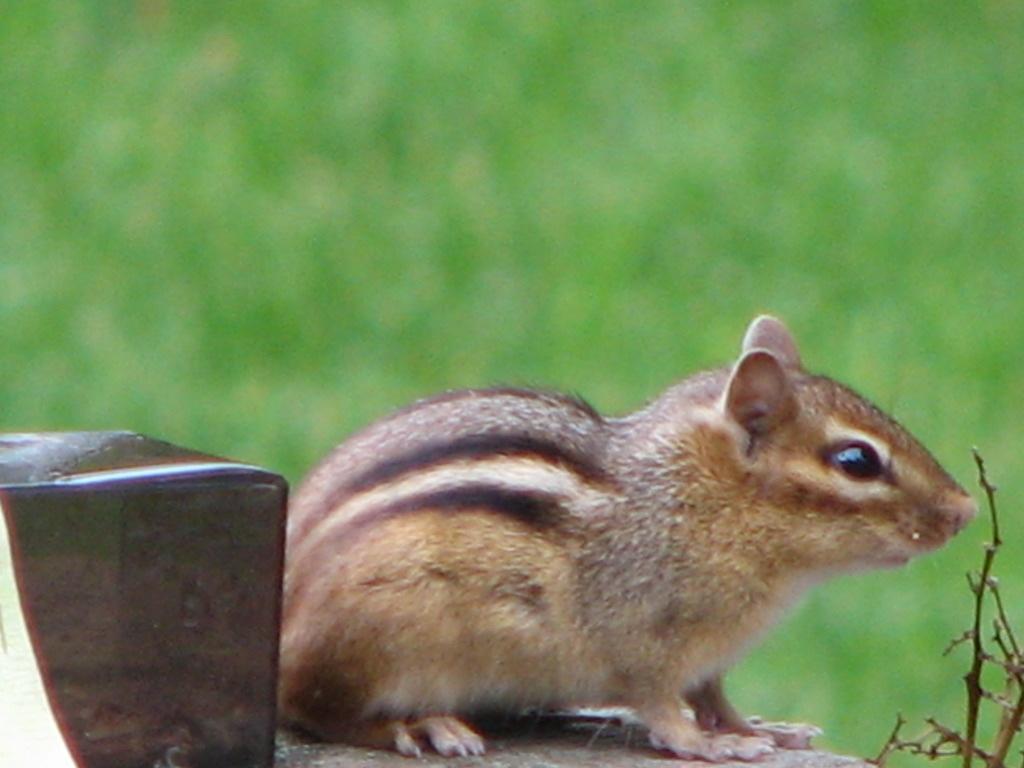Describe this image in one or two sentences. In this image there is a squirrel on a surface, beside that there is an object, in the background it is blurred. 